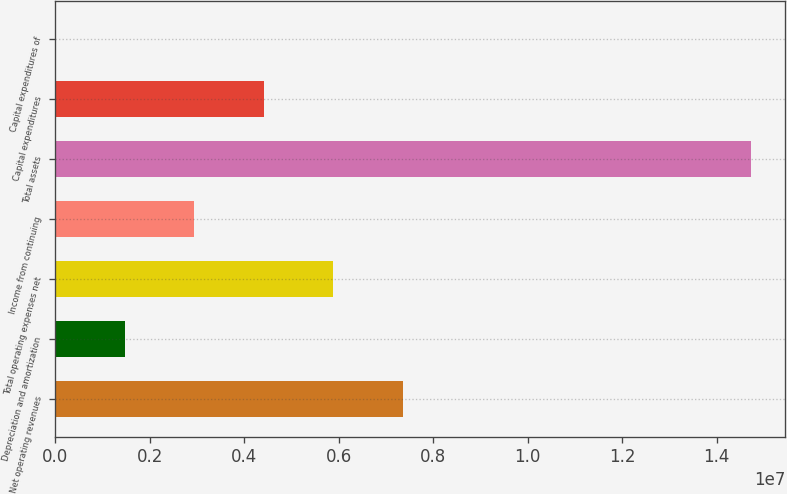Convert chart to OTSL. <chart><loc_0><loc_0><loc_500><loc_500><bar_chart><fcel>Net operating revenues<fcel>Depreciation and amortization<fcel>Total operating expenses net<fcel>Income from continuing<fcel>Total assets<fcel>Capital expenditures<fcel>Capital expenditures of<nl><fcel>7.36093e+06<fcel>1.47449e+06<fcel>5.88932e+06<fcel>2.9461e+06<fcel>1.4719e+07<fcel>4.41771e+06<fcel>2884<nl></chart> 